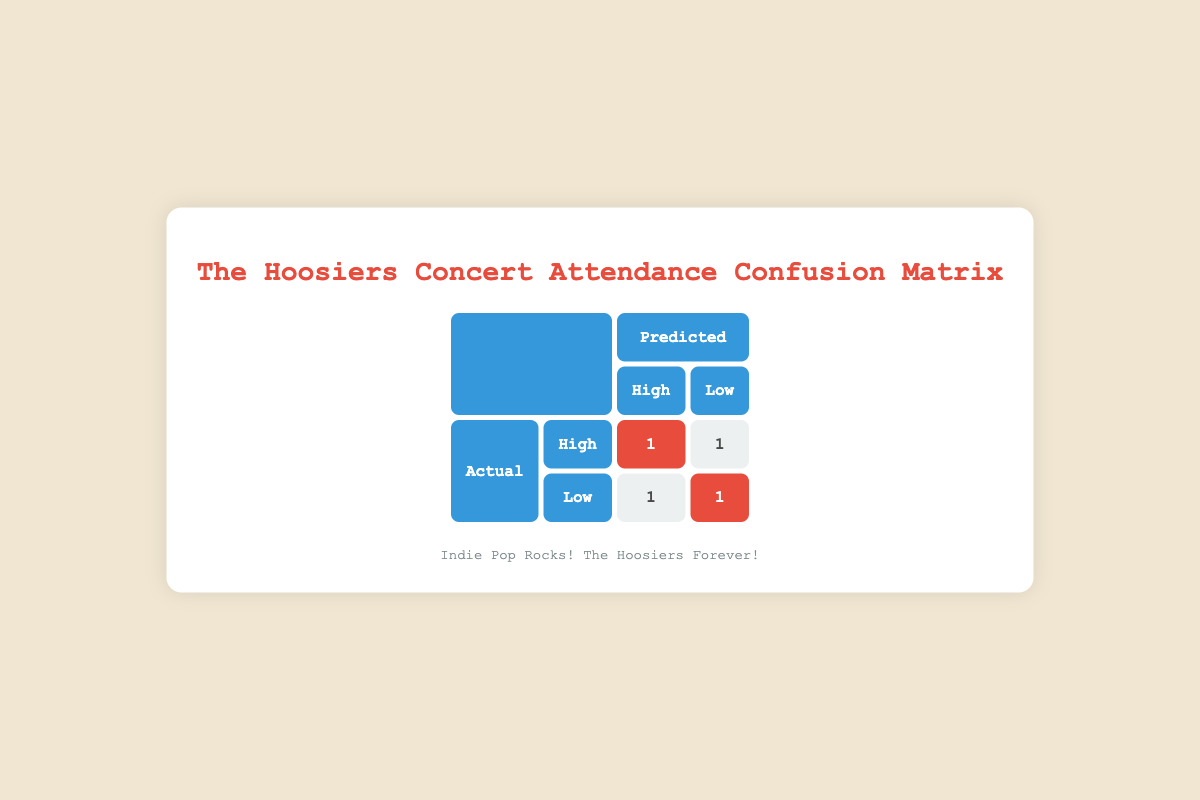What is the total number of predictions for high attendance? From the confusion matrix, we can see that there are two predictions for high attendance when the actual attendance was high (1) and one prediction for low attendance when the actual attendance was high (1) for The Hoosiers. Adding these together gives 2 + 1 = 3.
Answer: 3 How many times did The Hoosiers have actual attendance classified as low? In the table, there are two instances where the actual attendance for The Hoosiers is low: one where the predicted attendance is high (1) and another where the predicted attendance is low (1). Thus, the sum is 1 + 1 = 2.
Answer: 2 Is it accurate to say The Hoosiers had more high predications than low predictions? Looking at the table, The Hoosiers have 3 instances of high predicted attendance (1 for actual high and 2 for actual low) and 2 instances of low predicted attendance (1 for actual high and 1 for actual low). Since 3 is greater than 2, the statement is true.
Answer: Yes What is the proportion of correct high attendance predictions for The Hoosiers? The correct predictions for high attendance are 1 (actual high, predicted high). The total predictions for high attendance are 3 (1 actual high predicted high and 2 actual lows predicted high). Therefore, the proportion is 1/3 or approximately 0.33.
Answer: 0.33 Did The Hoosiers ever incorrectly predict high attendance when it was actually low? Yes, according to the table, there is one instance where the predicted attendance was high, but the actual attendance was low. This confirms the prediction was incorrect.
Answer: Yes 